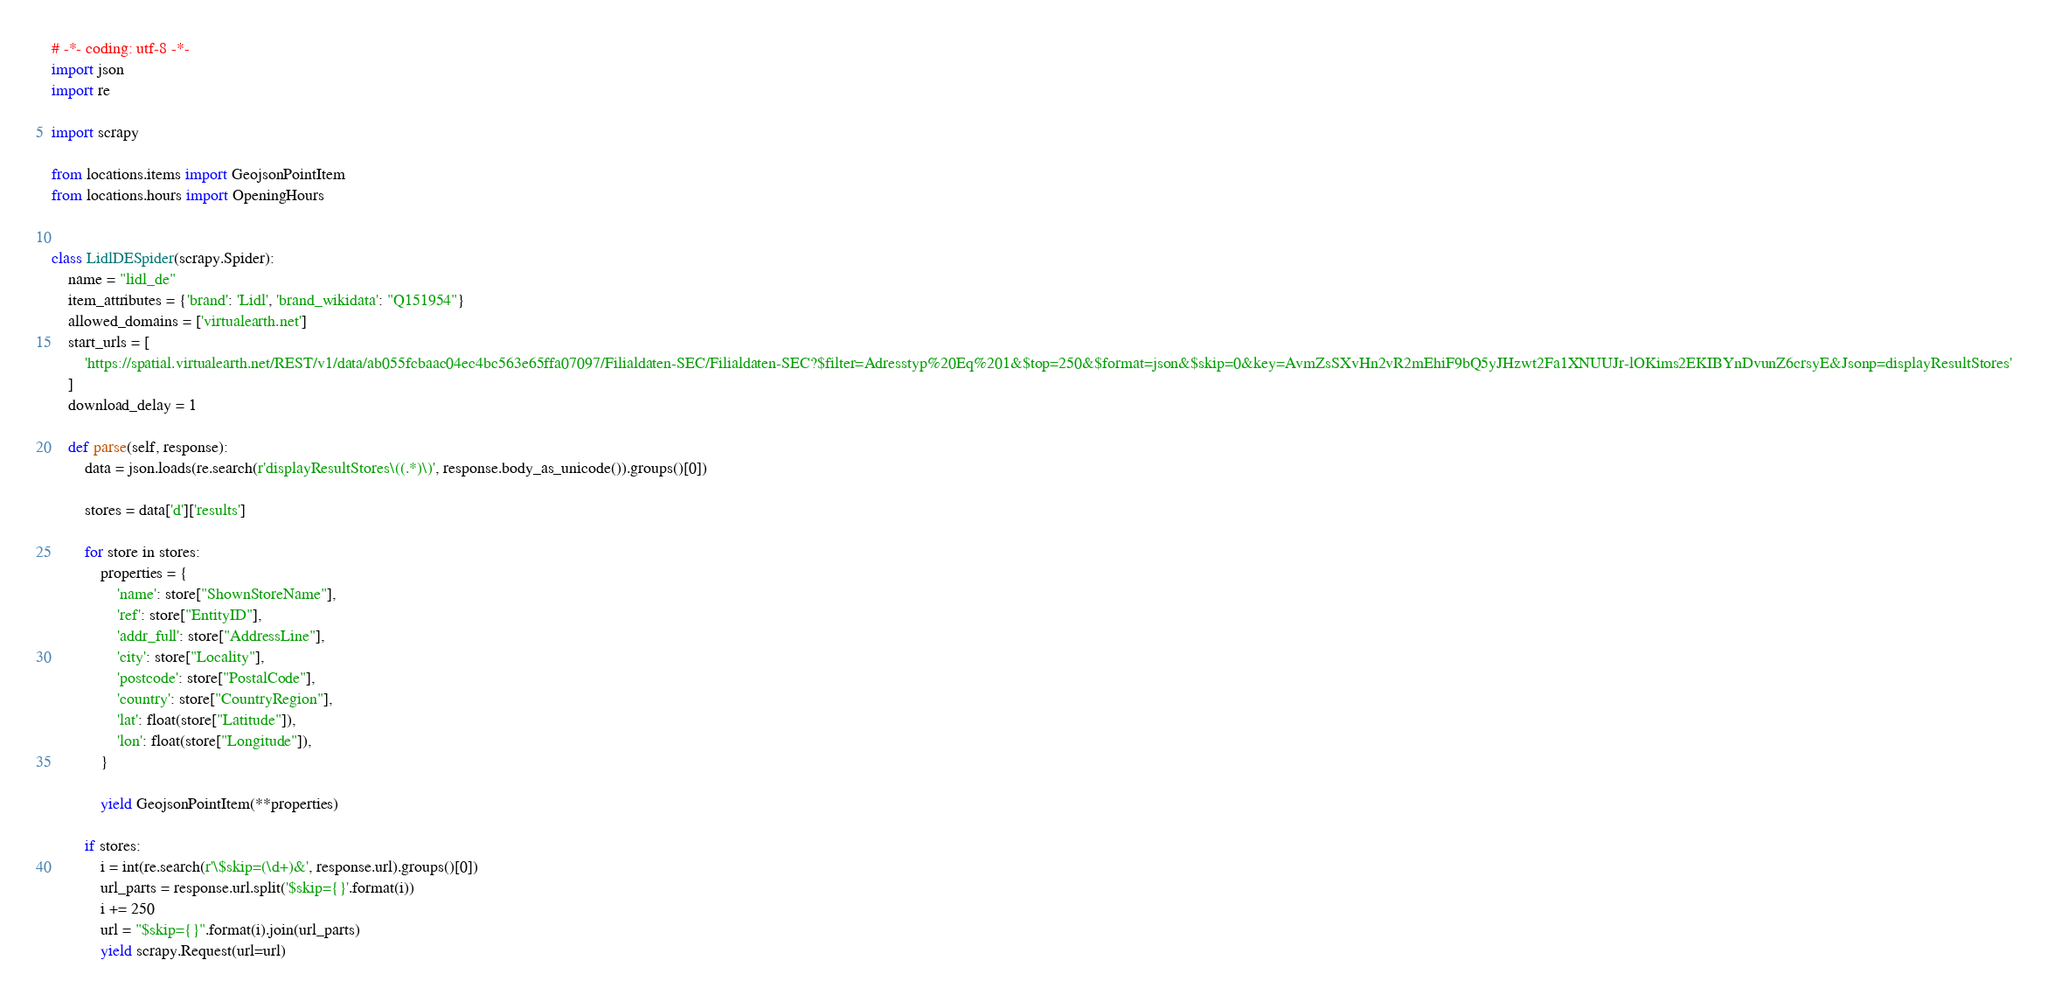<code> <loc_0><loc_0><loc_500><loc_500><_Python_># -*- coding: utf-8 -*-
import json
import re

import scrapy

from locations.items import GeojsonPointItem
from locations.hours import OpeningHours


class LidlDESpider(scrapy.Spider):
    name = "lidl_de"
    item_attributes = {'brand': 'Lidl', 'brand_wikidata': "Q151954"}
    allowed_domains = ['virtualearth.net']
    start_urls = [
        'https://spatial.virtualearth.net/REST/v1/data/ab055fcbaac04ec4bc563e65ffa07097/Filialdaten-SEC/Filialdaten-SEC?$filter=Adresstyp%20Eq%201&$top=250&$format=json&$skip=0&key=AvmZsSXvHn2vR2mEhiF9bQ5yJHzwt2Fa1XNUUJr-lOKims2EKIBYnDvunZ6crsyE&Jsonp=displayResultStores'
    ]
    download_delay = 1

    def parse(self, response):
        data = json.loads(re.search(r'displayResultStores\((.*)\)', response.body_as_unicode()).groups()[0])

        stores = data['d']['results']

        for store in stores:
            properties = {
                'name': store["ShownStoreName"],
                'ref': store["EntityID"],
                'addr_full': store["AddressLine"],
                'city': store["Locality"],
                'postcode': store["PostalCode"],
                'country': store["CountryRegion"],
                'lat': float(store["Latitude"]),
                'lon': float(store["Longitude"]),
            }

            yield GeojsonPointItem(**properties)

        if stores:
            i = int(re.search(r'\$skip=(\d+)&', response.url).groups()[0])
            url_parts = response.url.split('$skip={}'.format(i))
            i += 250
            url = "$skip={}".format(i).join(url_parts)
            yield scrapy.Request(url=url)
</code> 